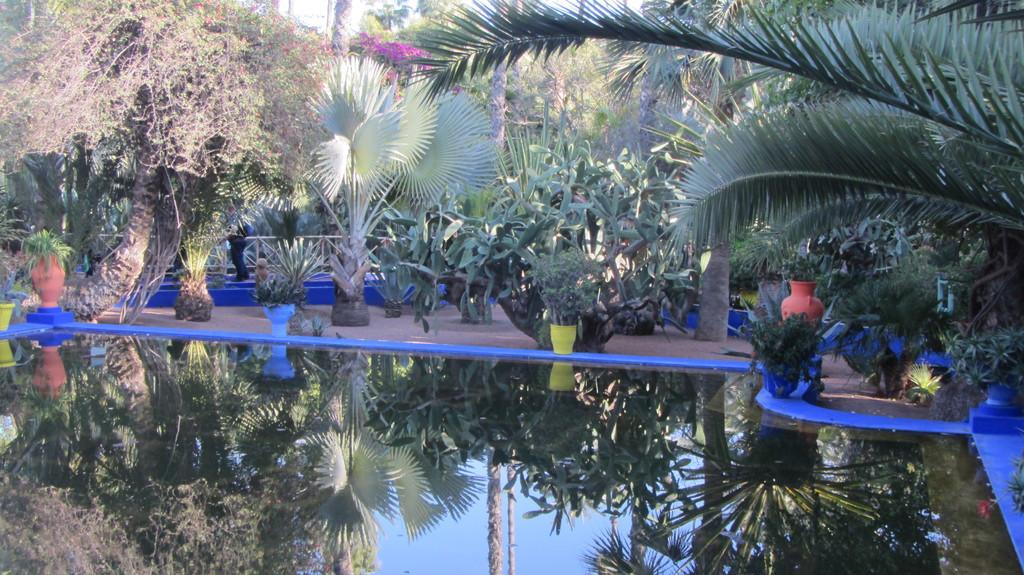What is at the bottom of the image? There is water at the bottom of the image. What can be seen in the background of the image? There are trees and flowers in the background of the image. Are there any people visible in the image? Yes, there is a person in the background of the image. What type of reaction can be seen from the flowers in the image? There is no reaction from the flowers in the image, as flowers do not have the ability to react. 